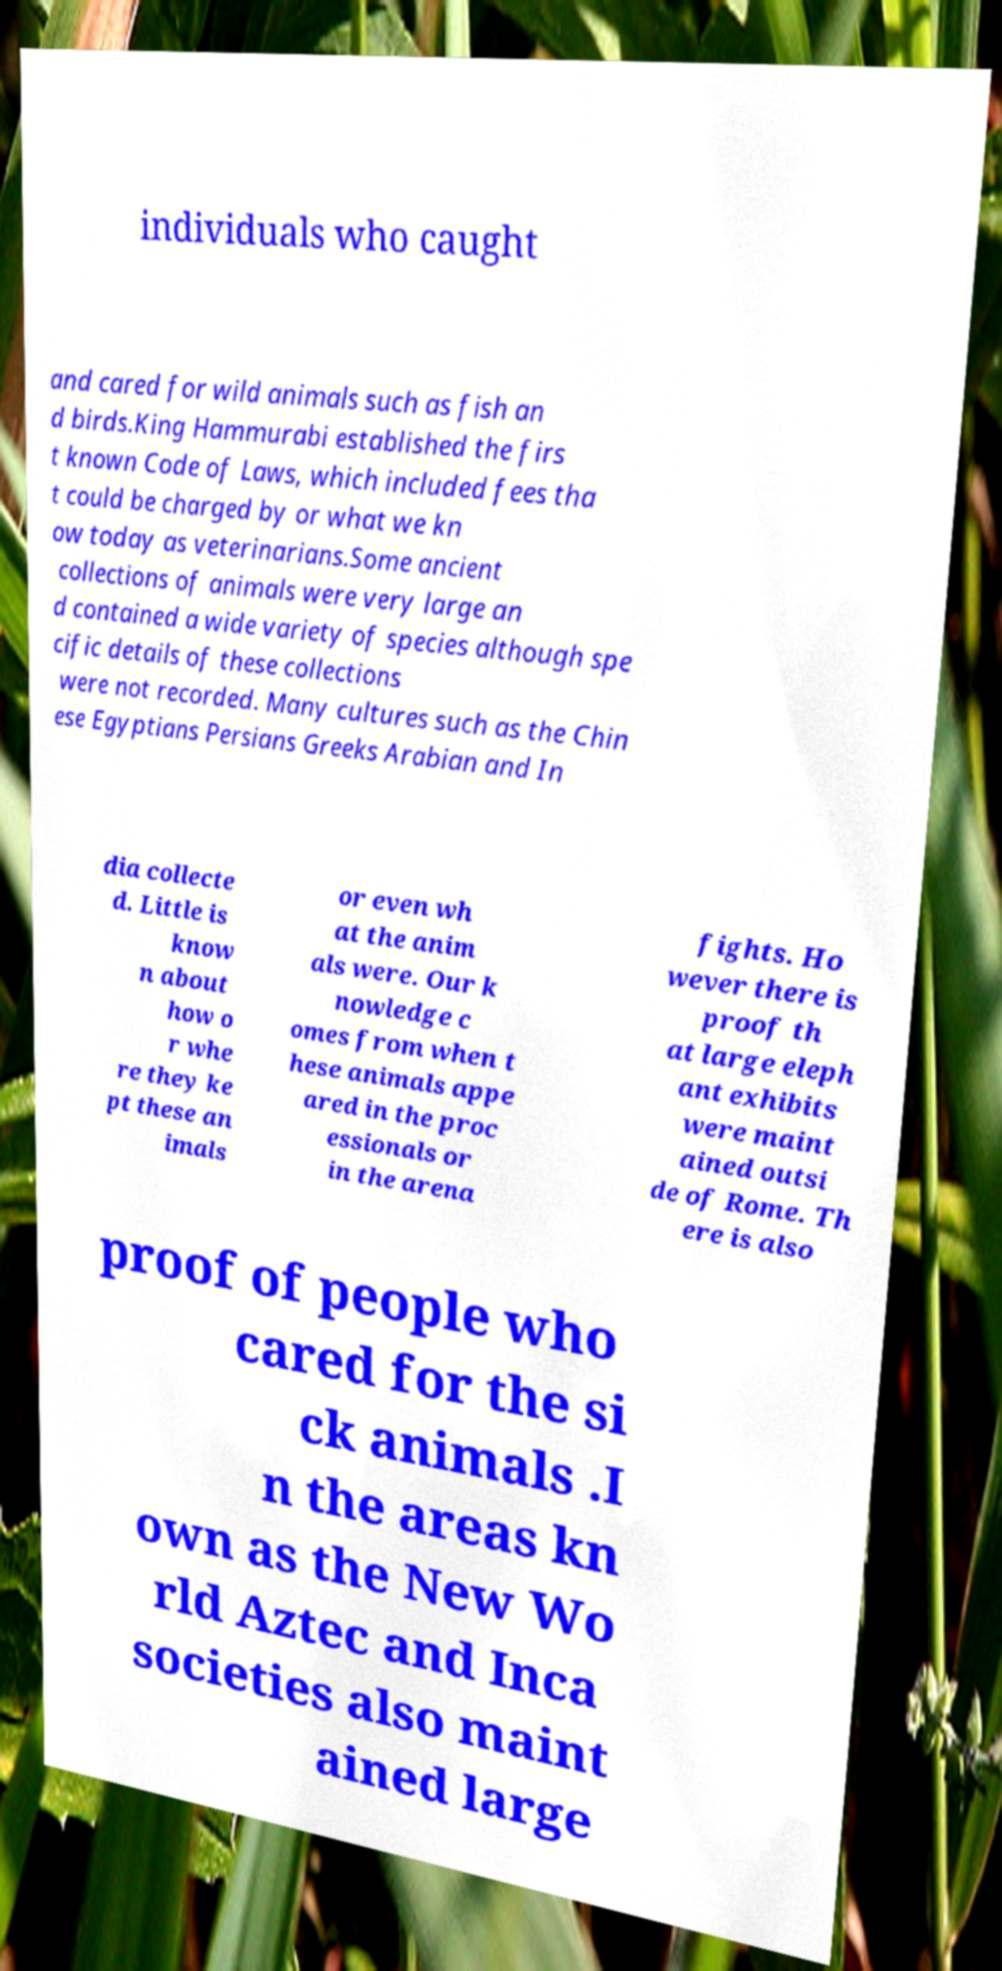Could you assist in decoding the text presented in this image and type it out clearly? individuals who caught and cared for wild animals such as fish an d birds.King Hammurabi established the firs t known Code of Laws, which included fees tha t could be charged by or what we kn ow today as veterinarians.Some ancient collections of animals were very large an d contained a wide variety of species although spe cific details of these collections were not recorded. Many cultures such as the Chin ese Egyptians Persians Greeks Arabian and In dia collecte d. Little is know n about how o r whe re they ke pt these an imals or even wh at the anim als were. Our k nowledge c omes from when t hese animals appe ared in the proc essionals or in the arena fights. Ho wever there is proof th at large eleph ant exhibits were maint ained outsi de of Rome. Th ere is also proof of people who cared for the si ck animals .I n the areas kn own as the New Wo rld Aztec and Inca societies also maint ained large 